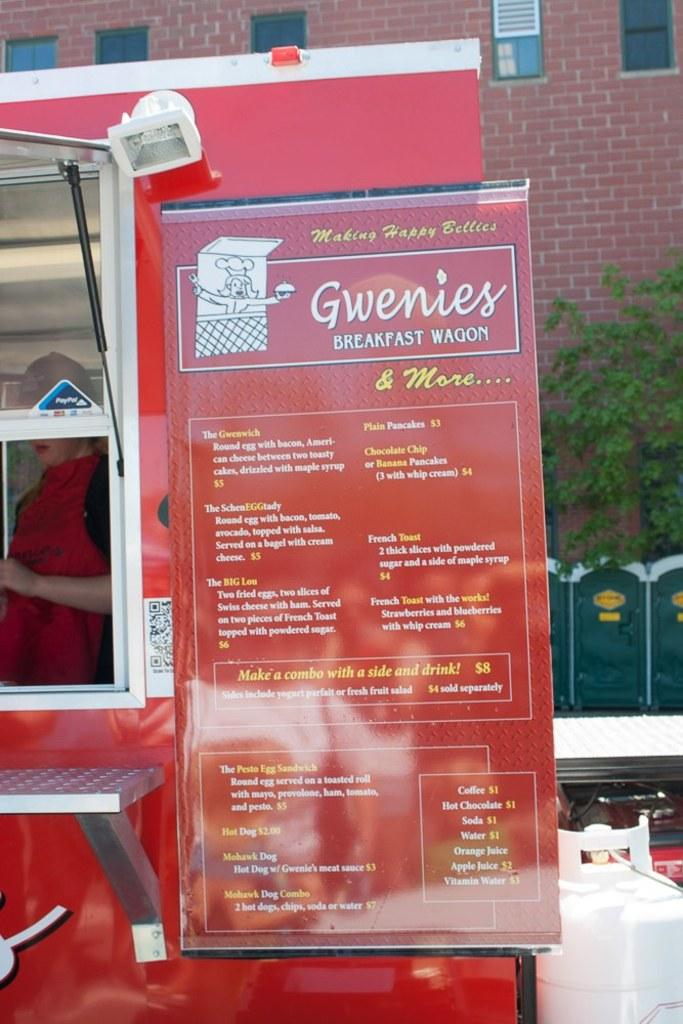What is hanging or displayed in the image? There is a banner in the image. What type of object is also present in the image? There is a vehicle in the image. What natural elements can be seen in the image? There are trees in the image. What type of structure is visible in the image? There is a building in the image. What architectural feature is present in the building? There are windows in the image. Where is the house located in the image? There is no house present in the image. What type of office can be seen in the image? There is no office present in the image. 